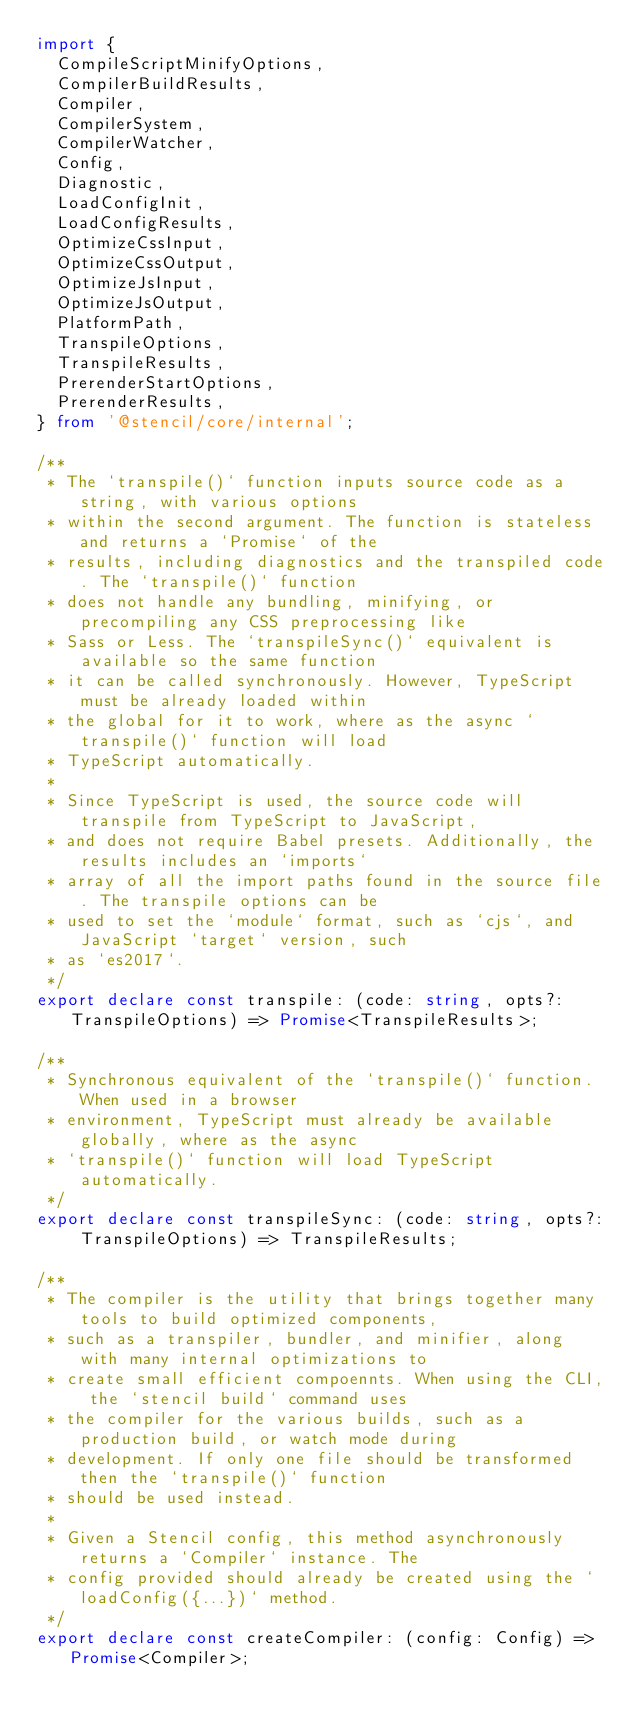<code> <loc_0><loc_0><loc_500><loc_500><_TypeScript_>import {
  CompileScriptMinifyOptions,
  CompilerBuildResults,
  Compiler,
  CompilerSystem,
  CompilerWatcher,
  Config,
  Diagnostic,
  LoadConfigInit,
  LoadConfigResults,
  OptimizeCssInput,
  OptimizeCssOutput,
  OptimizeJsInput,
  OptimizeJsOutput,
  PlatformPath,
  TranspileOptions,
  TranspileResults,
  PrerenderStartOptions,
  PrerenderResults,
} from '@stencil/core/internal';

/**
 * The `transpile()` function inputs source code as a string, with various options
 * within the second argument. The function is stateless and returns a `Promise` of the
 * results, including diagnostics and the transpiled code. The `transpile()` function
 * does not handle any bundling, minifying, or precompiling any CSS preprocessing like
 * Sass or Less. The `transpileSync()` equivalent is available so the same function
 * it can be called synchronously. However, TypeScript must be already loaded within
 * the global for it to work, where as the async `transpile()` function will load
 * TypeScript automatically.
 *
 * Since TypeScript is used, the source code will transpile from TypeScript to JavaScript,
 * and does not require Babel presets. Additionally, the results includes an `imports`
 * array of all the import paths found in the source file. The transpile options can be
 * used to set the `module` format, such as `cjs`, and JavaScript `target` version, such
 * as `es2017`.
 */
export declare const transpile: (code: string, opts?: TranspileOptions) => Promise<TranspileResults>;

/**
 * Synchronous equivalent of the `transpile()` function. When used in a browser
 * environment, TypeScript must already be available globally, where as the async
 * `transpile()` function will load TypeScript automatically.
 */
export declare const transpileSync: (code: string, opts?: TranspileOptions) => TranspileResults;

/**
 * The compiler is the utility that brings together many tools to build optimized components,
 * such as a transpiler, bundler, and minifier, along with many internal optimizations to
 * create small efficient compoennts. When using the CLI, the `stencil build` command uses
 * the compiler for the various builds, such as a production build, or watch mode during
 * development. If only one file should be transformed then the `transpile()` function
 * should be used instead.
 *
 * Given a Stencil config, this method asynchronously returns a `Compiler` instance. The
 * config provided should already be created using the `loadConfig({...})` method.
 */
export declare const createCompiler: (config: Config) => Promise<Compiler>;
</code> 